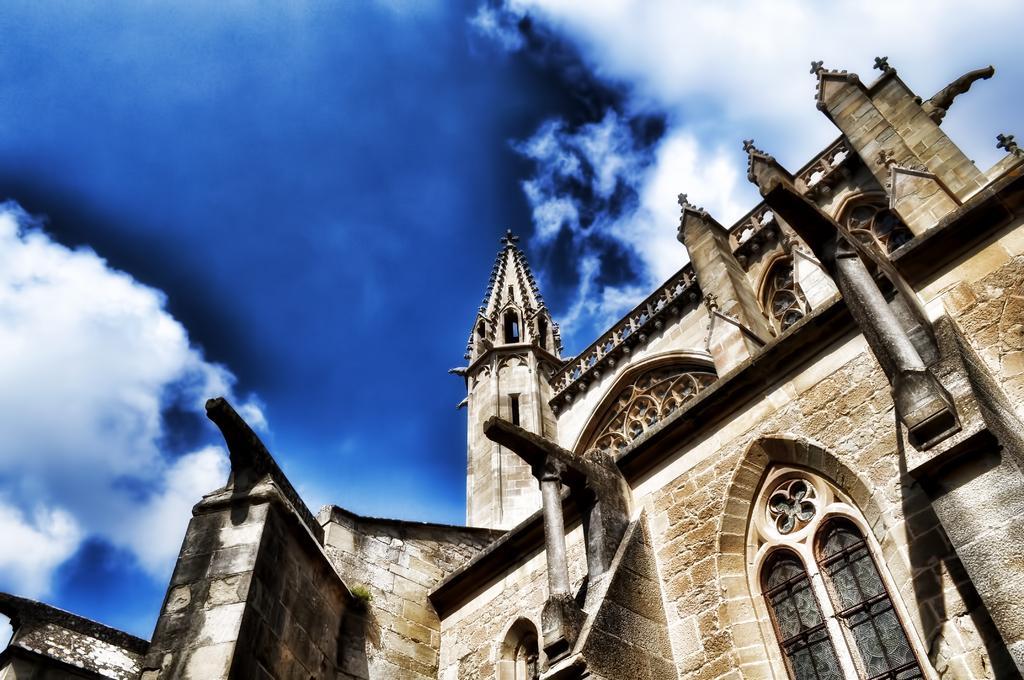Please provide a concise description of this image. There is a building in the foreground area of the image and the sky in the background. 